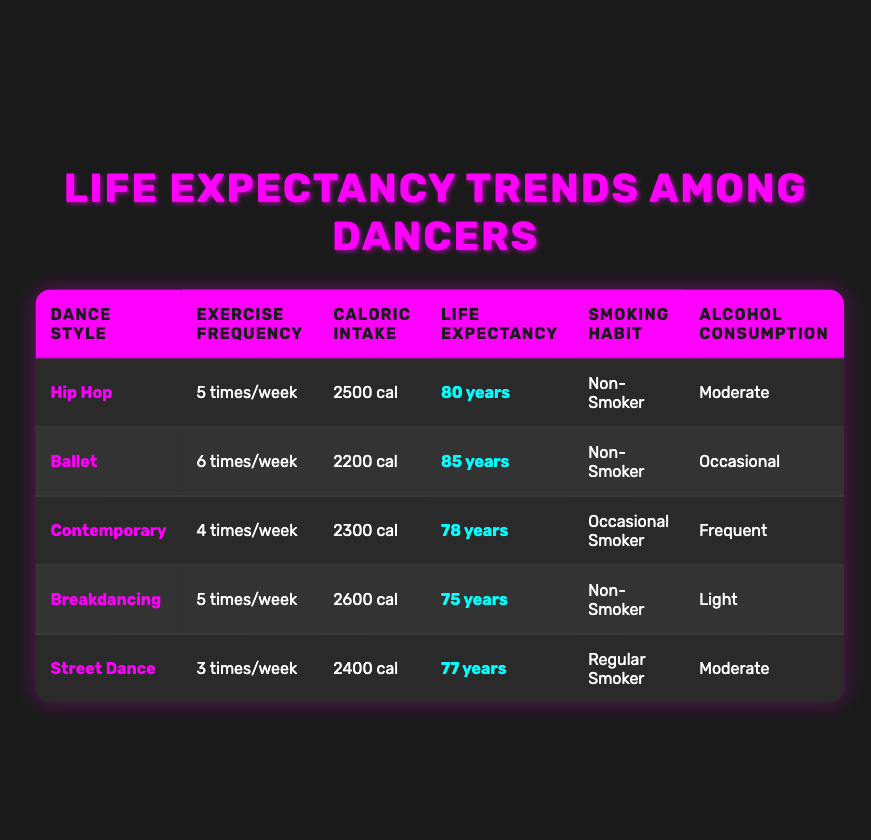What is the life expectancy of Ballet dancers? The life expectancy for Ballet dancers is listed in the table under the life expectancy years column for the Ballet entry, which shows 85 years.
Answer: 85 years Which dance style has the highest average caloric intake? The average caloric intake is shown in the average caloric intake column. By comparing the values in that column, Breakdancing has the highest average caloric intake at 2600 cal.
Answer: 2600 cal How many times do Contemporary dancers exercise per week? The exercise frequency for Contemporary dancers can be found in the exercise frequency per week column. It states they exercise 4 times per week.
Answer: 4 times/week Is there any dance style among the listed that shows a life expectancy of less than 80 years? By checking the life expectancy years column, both Contemporary (78 years) and Breakdancing (75 years) have life expectancies less than 80 years, so the answer is yes.
Answer: Yes What is the average life expectancy of dancers who smoke regularly? The only dancer style that has a regular smoking habit is Street Dance, which shows a life expectancy of 77 years. Since this is the only entry, the average is 77.
Answer: 77 years What is the difference in life expectancy between Hip Hop and Breakdancing dancers? To find the difference in life expectancy, subtract the life expectancy of Breakdancing (75 years) from that of Hip Hop (80 years). So, 80 - 75 = 5 years.
Answer: 5 years Which dance style has the lowest exercise frequency, and what is that frequency? Viewing the exercise frequency per week column, Street Dance has the lowest frequency at 3 times per week.
Answer: 3 times/week How many dancers have a non-smoking habit? There are three styles listed with a non-smoking habit: Hip Hop, Ballet, and Breakdancing. Therefore, there are 3 dancers with a non-smoking habit.
Answer: 3 dancers 